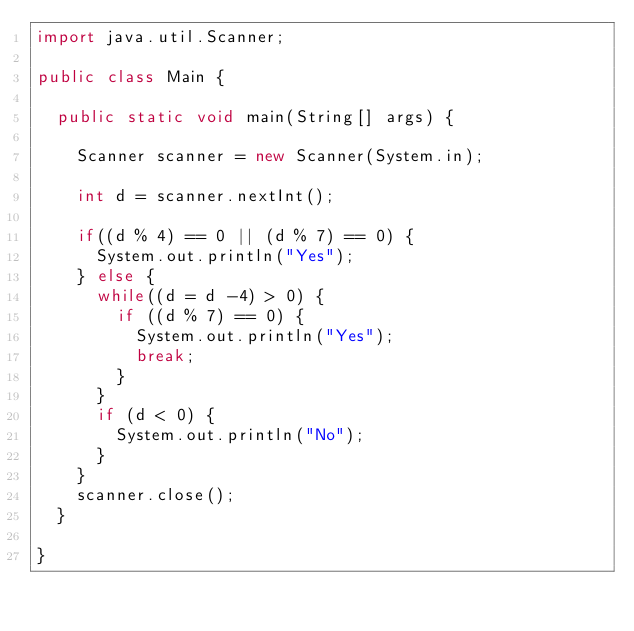Convert code to text. <code><loc_0><loc_0><loc_500><loc_500><_Java_>import java.util.Scanner;

public class Main {

	public static void main(String[] args) {

		Scanner scanner = new Scanner(System.in);

		int d = scanner.nextInt();

		if((d % 4) == 0 || (d % 7) == 0) {
			System.out.println("Yes");
		} else {
			while((d = d -4) > 0) {
				if ((d % 7) == 0) {
					System.out.println("Yes");
					break;
				}
			}
			if (d < 0) {
				System.out.println("No");
			}
		}
		scanner.close();
	}

}</code> 